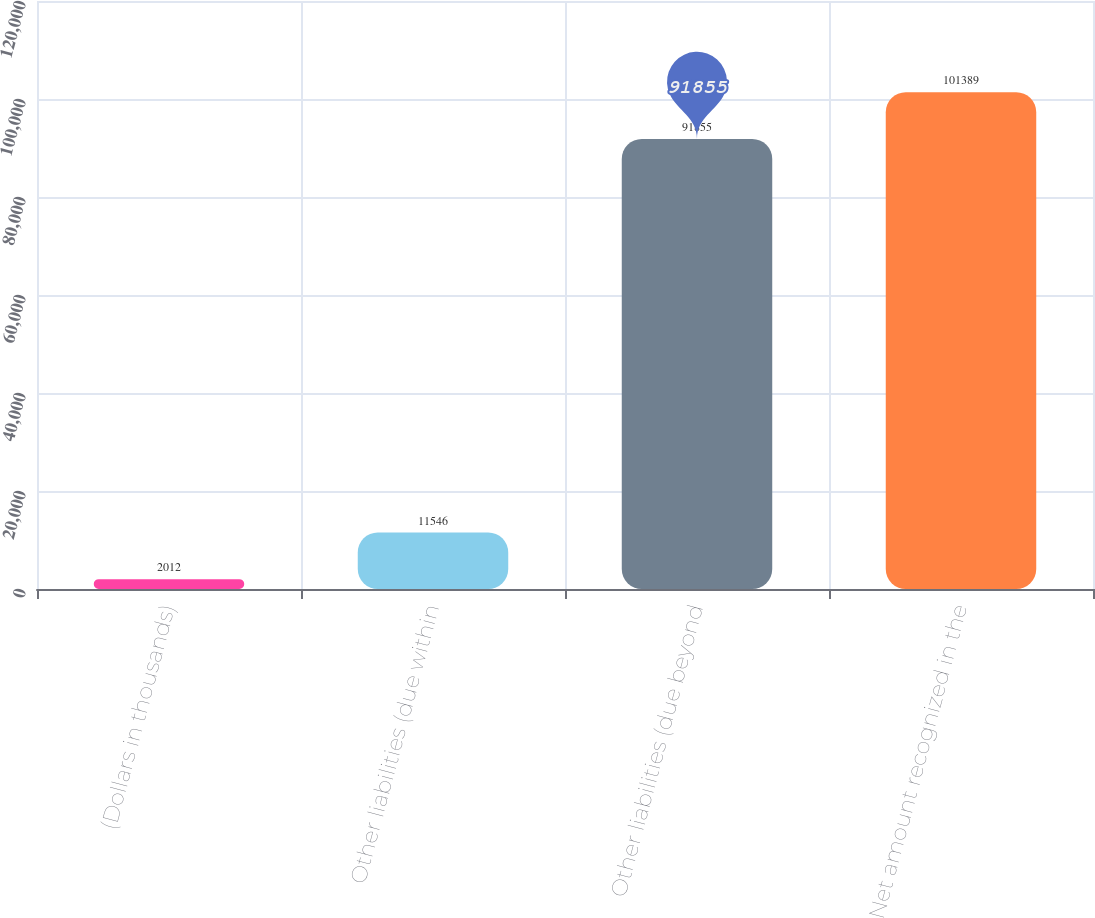Convert chart to OTSL. <chart><loc_0><loc_0><loc_500><loc_500><bar_chart><fcel>(Dollars in thousands)<fcel>Other liabilities (due within<fcel>Other liabilities (due beyond<fcel>Net amount recognized in the<nl><fcel>2012<fcel>11546<fcel>91855<fcel>101389<nl></chart> 